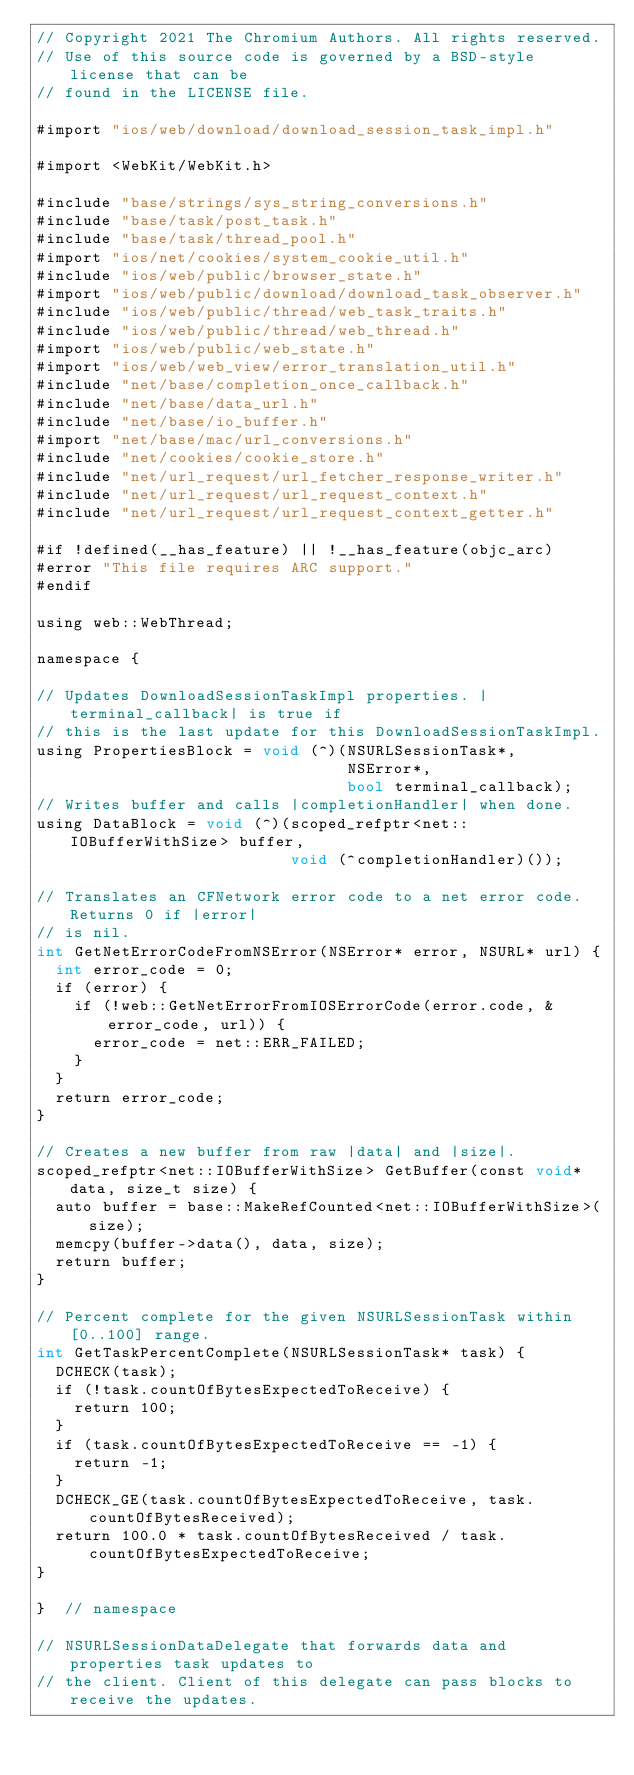<code> <loc_0><loc_0><loc_500><loc_500><_ObjectiveC_>// Copyright 2021 The Chromium Authors. All rights reserved.
// Use of this source code is governed by a BSD-style license that can be
// found in the LICENSE file.

#import "ios/web/download/download_session_task_impl.h"

#import <WebKit/WebKit.h>

#include "base/strings/sys_string_conversions.h"
#include "base/task/post_task.h"
#include "base/task/thread_pool.h"
#import "ios/net/cookies/system_cookie_util.h"
#include "ios/web/public/browser_state.h"
#import "ios/web/public/download/download_task_observer.h"
#include "ios/web/public/thread/web_task_traits.h"
#include "ios/web/public/thread/web_thread.h"
#import "ios/web/public/web_state.h"
#import "ios/web/web_view/error_translation_util.h"
#include "net/base/completion_once_callback.h"
#include "net/base/data_url.h"
#include "net/base/io_buffer.h"
#import "net/base/mac/url_conversions.h"
#include "net/cookies/cookie_store.h"
#include "net/url_request/url_fetcher_response_writer.h"
#include "net/url_request/url_request_context.h"
#include "net/url_request/url_request_context_getter.h"

#if !defined(__has_feature) || !__has_feature(objc_arc)
#error "This file requires ARC support."
#endif

using web::WebThread;

namespace {

// Updates DownloadSessionTaskImpl properties. |terminal_callback| is true if
// this is the last update for this DownloadSessionTaskImpl.
using PropertiesBlock = void (^)(NSURLSessionTask*,
                                 NSError*,
                                 bool terminal_callback);
// Writes buffer and calls |completionHandler| when done.
using DataBlock = void (^)(scoped_refptr<net::IOBufferWithSize> buffer,
                           void (^completionHandler)());

// Translates an CFNetwork error code to a net error code. Returns 0 if |error|
// is nil.
int GetNetErrorCodeFromNSError(NSError* error, NSURL* url) {
  int error_code = 0;
  if (error) {
    if (!web::GetNetErrorFromIOSErrorCode(error.code, &error_code, url)) {
      error_code = net::ERR_FAILED;
    }
  }
  return error_code;
}

// Creates a new buffer from raw |data| and |size|.
scoped_refptr<net::IOBufferWithSize> GetBuffer(const void* data, size_t size) {
  auto buffer = base::MakeRefCounted<net::IOBufferWithSize>(size);
  memcpy(buffer->data(), data, size);
  return buffer;
}

// Percent complete for the given NSURLSessionTask within [0..100] range.
int GetTaskPercentComplete(NSURLSessionTask* task) {
  DCHECK(task);
  if (!task.countOfBytesExpectedToReceive) {
    return 100;
  }
  if (task.countOfBytesExpectedToReceive == -1) {
    return -1;
  }
  DCHECK_GE(task.countOfBytesExpectedToReceive, task.countOfBytesReceived);
  return 100.0 * task.countOfBytesReceived / task.countOfBytesExpectedToReceive;
}

}  // namespace

// NSURLSessionDataDelegate that forwards data and properties task updates to
// the client. Client of this delegate can pass blocks to receive the updates.</code> 